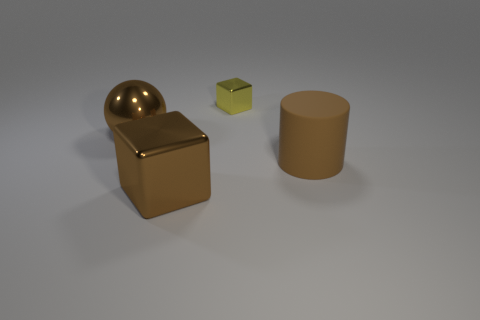Add 1 brown cylinders. How many objects exist? 5 Subtract all spheres. How many objects are left? 3 Add 2 large balls. How many large balls are left? 3 Add 4 small green metallic spheres. How many small green metallic spheres exist? 4 Subtract 0 purple balls. How many objects are left? 4 Subtract all cyan metal cylinders. Subtract all big brown metallic balls. How many objects are left? 3 